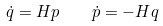<formula> <loc_0><loc_0><loc_500><loc_500>\dot { q } = H p \quad \dot { p } = - H q</formula> 